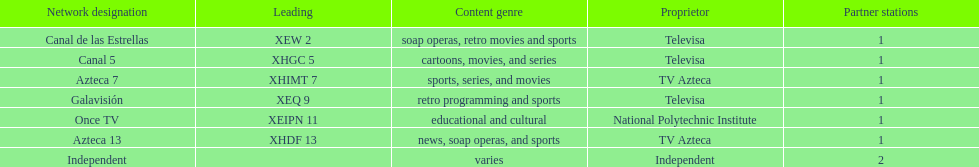Could you help me parse every detail presented in this table? {'header': ['Network designation', 'Leading', 'Content genre', 'Proprietor', 'Partner stations'], 'rows': [['Canal de las Estrellas', 'XEW 2', 'soap operas, retro movies and sports', 'Televisa', '1'], ['Canal 5', 'XHGC 5', 'cartoons, movies, and series', 'Televisa', '1'], ['Azteca 7', 'XHIMT 7', 'sports, series, and movies', 'TV Azteca', '1'], ['Galavisión', 'XEQ 9', 'retro programming and sports', 'Televisa', '1'], ['Once TV', 'XEIPN 11', 'educational and cultural', 'National Polytechnic Institute', '1'], ['Azteca 13', 'XHDF 13', 'news, soap operas, and sports', 'TV Azteca', '1'], ['Independent', '', 'varies', 'Independent', '2']]} What is the only network owned by national polytechnic institute? Once TV. 